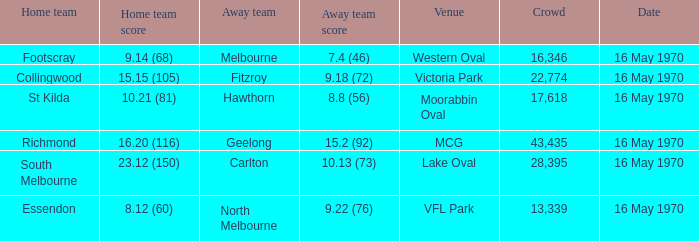What did the away team score when the home team was south melbourne? 10.13 (73). 